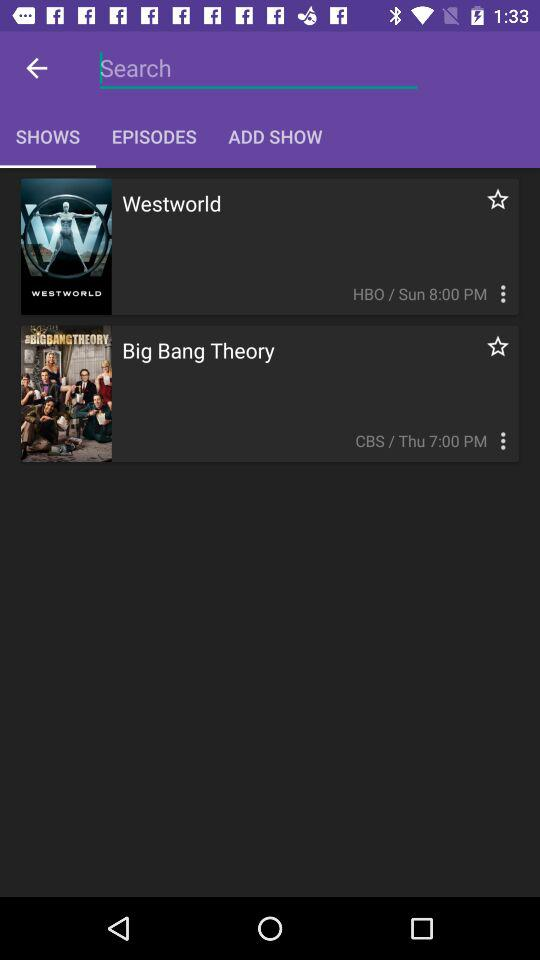Which tab is selected? The selected tab is "SHOWS". 